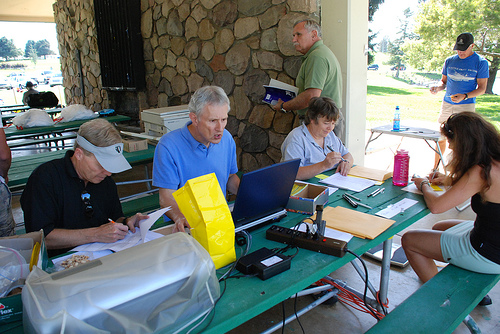<image>
Is the wall to the right of the man? Yes. From this viewpoint, the wall is positioned to the right side relative to the man. 